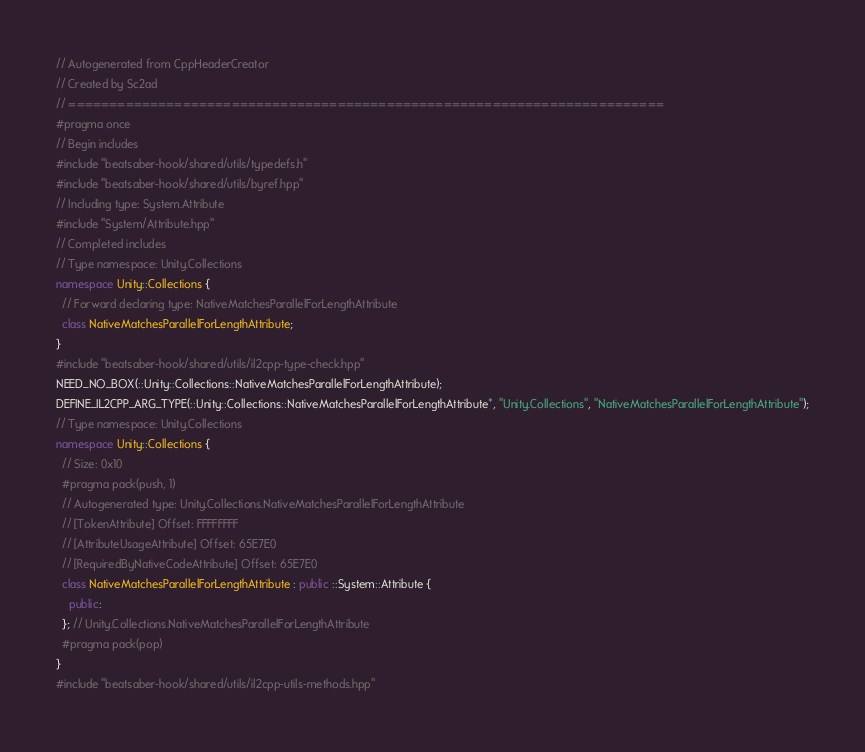<code> <loc_0><loc_0><loc_500><loc_500><_C++_>// Autogenerated from CppHeaderCreator
// Created by Sc2ad
// =========================================================================
#pragma once
// Begin includes
#include "beatsaber-hook/shared/utils/typedefs.h"
#include "beatsaber-hook/shared/utils/byref.hpp"
// Including type: System.Attribute
#include "System/Attribute.hpp"
// Completed includes
// Type namespace: Unity.Collections
namespace Unity::Collections {
  // Forward declaring type: NativeMatchesParallelForLengthAttribute
  class NativeMatchesParallelForLengthAttribute;
}
#include "beatsaber-hook/shared/utils/il2cpp-type-check.hpp"
NEED_NO_BOX(::Unity::Collections::NativeMatchesParallelForLengthAttribute);
DEFINE_IL2CPP_ARG_TYPE(::Unity::Collections::NativeMatchesParallelForLengthAttribute*, "Unity.Collections", "NativeMatchesParallelForLengthAttribute");
// Type namespace: Unity.Collections
namespace Unity::Collections {
  // Size: 0x10
  #pragma pack(push, 1)
  // Autogenerated type: Unity.Collections.NativeMatchesParallelForLengthAttribute
  // [TokenAttribute] Offset: FFFFFFFF
  // [AttributeUsageAttribute] Offset: 65E7E0
  // [RequiredByNativeCodeAttribute] Offset: 65E7E0
  class NativeMatchesParallelForLengthAttribute : public ::System::Attribute {
    public:
  }; // Unity.Collections.NativeMatchesParallelForLengthAttribute
  #pragma pack(pop)
}
#include "beatsaber-hook/shared/utils/il2cpp-utils-methods.hpp"
</code> 